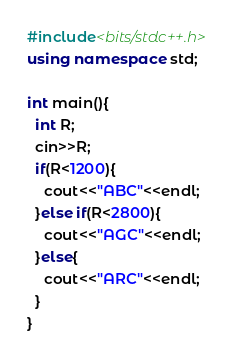Convert code to text. <code><loc_0><loc_0><loc_500><loc_500><_C++_>#include<bits/stdc++.h>
using namespace std;

int main(){
  int R;
  cin>>R;
  if(R<1200){
    cout<<"ABC"<<endl;
  }else if(R<2800){
    cout<<"AGC"<<endl;
  }else{
    cout<<"ARC"<<endl;
  }
}</code> 